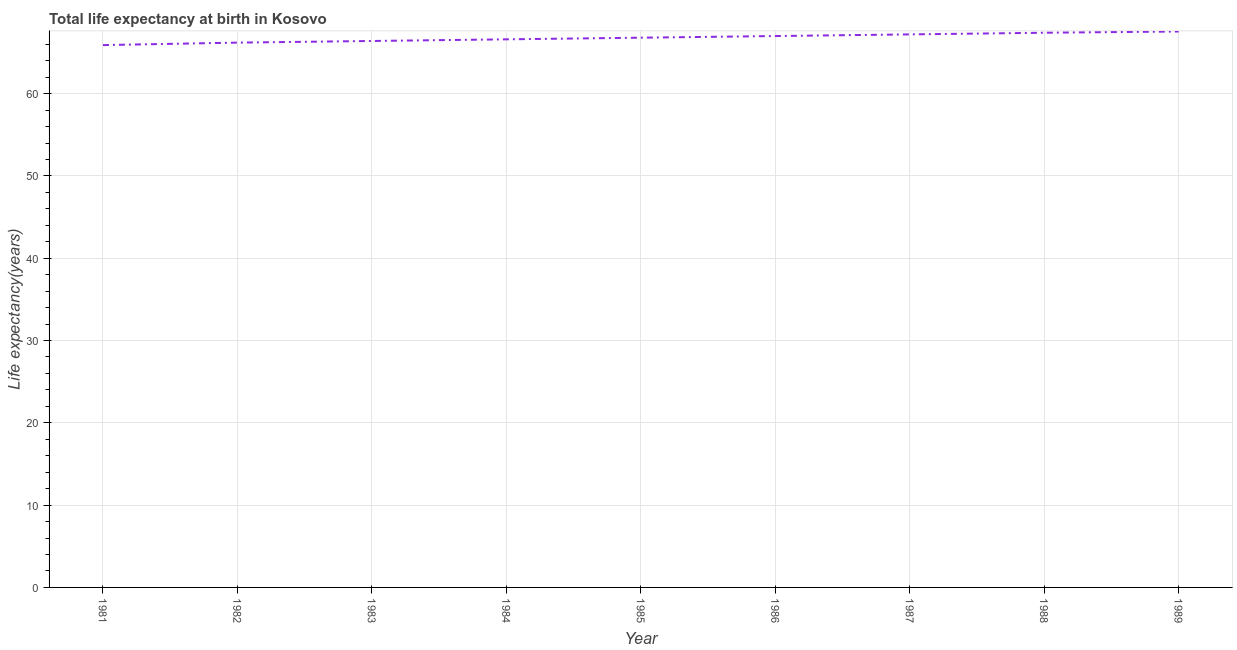What is the life expectancy at birth in 1985?
Offer a very short reply. 66.8. Across all years, what is the maximum life expectancy at birth?
Offer a very short reply. 67.55. Across all years, what is the minimum life expectancy at birth?
Your answer should be compact. 65.9. In which year was the life expectancy at birth maximum?
Your response must be concise. 1989. In which year was the life expectancy at birth minimum?
Your response must be concise. 1981. What is the sum of the life expectancy at birth?
Make the answer very short. 601.03. What is the difference between the life expectancy at birth in 1984 and 1988?
Your response must be concise. -0.8. What is the average life expectancy at birth per year?
Offer a terse response. 66.78. What is the median life expectancy at birth?
Provide a short and direct response. 66.8. Do a majority of the years between 1982 and 1986 (inclusive) have life expectancy at birth greater than 64 years?
Make the answer very short. Yes. What is the ratio of the life expectancy at birth in 1986 to that in 1987?
Offer a very short reply. 1. Is the life expectancy at birth in 1984 less than that in 1986?
Provide a short and direct response. Yes. What is the difference between the highest and the second highest life expectancy at birth?
Offer a very short reply. 0.15. What is the difference between the highest and the lowest life expectancy at birth?
Your response must be concise. 1.65. How many years are there in the graph?
Keep it short and to the point. 9. Does the graph contain grids?
Keep it short and to the point. Yes. What is the title of the graph?
Your answer should be very brief. Total life expectancy at birth in Kosovo. What is the label or title of the X-axis?
Offer a terse response. Year. What is the label or title of the Y-axis?
Provide a short and direct response. Life expectancy(years). What is the Life expectancy(years) of 1981?
Offer a very short reply. 65.9. What is the Life expectancy(years) of 1982?
Offer a very short reply. 66.2. What is the Life expectancy(years) of 1983?
Keep it short and to the point. 66.4. What is the Life expectancy(years) in 1984?
Offer a very short reply. 66.6. What is the Life expectancy(years) in 1985?
Keep it short and to the point. 66.8. What is the Life expectancy(years) in 1986?
Provide a short and direct response. 67. What is the Life expectancy(years) in 1987?
Provide a short and direct response. 67.2. What is the Life expectancy(years) of 1988?
Offer a very short reply. 67.4. What is the Life expectancy(years) of 1989?
Make the answer very short. 67.55. What is the difference between the Life expectancy(years) in 1981 and 1983?
Offer a terse response. -0.5. What is the difference between the Life expectancy(years) in 1981 and 1985?
Offer a very short reply. -0.9. What is the difference between the Life expectancy(years) in 1981 and 1986?
Your response must be concise. -1.1. What is the difference between the Life expectancy(years) in 1981 and 1987?
Offer a very short reply. -1.3. What is the difference between the Life expectancy(years) in 1981 and 1988?
Your answer should be compact. -1.5. What is the difference between the Life expectancy(years) in 1981 and 1989?
Ensure brevity in your answer.  -1.65. What is the difference between the Life expectancy(years) in 1982 and 1984?
Provide a succinct answer. -0.4. What is the difference between the Life expectancy(years) in 1982 and 1986?
Your response must be concise. -0.8. What is the difference between the Life expectancy(years) in 1982 and 1987?
Give a very brief answer. -1. What is the difference between the Life expectancy(years) in 1982 and 1988?
Your answer should be compact. -1.2. What is the difference between the Life expectancy(years) in 1982 and 1989?
Keep it short and to the point. -1.35. What is the difference between the Life expectancy(years) in 1983 and 1984?
Make the answer very short. -0.2. What is the difference between the Life expectancy(years) in 1983 and 1987?
Ensure brevity in your answer.  -0.8. What is the difference between the Life expectancy(years) in 1983 and 1989?
Provide a succinct answer. -1.15. What is the difference between the Life expectancy(years) in 1984 and 1985?
Your answer should be very brief. -0.2. What is the difference between the Life expectancy(years) in 1984 and 1989?
Provide a short and direct response. -0.95. What is the difference between the Life expectancy(years) in 1985 and 1986?
Your answer should be compact. -0.2. What is the difference between the Life expectancy(years) in 1985 and 1987?
Ensure brevity in your answer.  -0.4. What is the difference between the Life expectancy(years) in 1985 and 1989?
Ensure brevity in your answer.  -0.75. What is the difference between the Life expectancy(years) in 1986 and 1987?
Make the answer very short. -0.2. What is the difference between the Life expectancy(years) in 1986 and 1988?
Ensure brevity in your answer.  -0.4. What is the difference between the Life expectancy(years) in 1986 and 1989?
Provide a succinct answer. -0.55. What is the difference between the Life expectancy(years) in 1987 and 1988?
Offer a terse response. -0.2. What is the difference between the Life expectancy(years) in 1987 and 1989?
Offer a very short reply. -0.35. What is the difference between the Life expectancy(years) in 1988 and 1989?
Provide a succinct answer. -0.15. What is the ratio of the Life expectancy(years) in 1981 to that in 1983?
Offer a very short reply. 0.99. What is the ratio of the Life expectancy(years) in 1981 to that in 1984?
Your answer should be very brief. 0.99. What is the ratio of the Life expectancy(years) in 1981 to that in 1985?
Your response must be concise. 0.99. What is the ratio of the Life expectancy(years) in 1981 to that in 1986?
Give a very brief answer. 0.98. What is the ratio of the Life expectancy(years) in 1981 to that in 1987?
Provide a short and direct response. 0.98. What is the ratio of the Life expectancy(years) in 1981 to that in 1988?
Make the answer very short. 0.98. What is the ratio of the Life expectancy(years) in 1982 to that in 1985?
Give a very brief answer. 0.99. What is the ratio of the Life expectancy(years) in 1982 to that in 1986?
Your response must be concise. 0.99. What is the ratio of the Life expectancy(years) in 1982 to that in 1988?
Ensure brevity in your answer.  0.98. What is the ratio of the Life expectancy(years) in 1983 to that in 1985?
Keep it short and to the point. 0.99. What is the ratio of the Life expectancy(years) in 1983 to that in 1987?
Your answer should be very brief. 0.99. What is the ratio of the Life expectancy(years) in 1983 to that in 1989?
Ensure brevity in your answer.  0.98. What is the ratio of the Life expectancy(years) in 1984 to that in 1985?
Offer a very short reply. 1. What is the ratio of the Life expectancy(years) in 1984 to that in 1986?
Offer a very short reply. 0.99. What is the ratio of the Life expectancy(years) in 1984 to that in 1987?
Keep it short and to the point. 0.99. What is the ratio of the Life expectancy(years) in 1985 to that in 1986?
Your answer should be compact. 1. What is the ratio of the Life expectancy(years) in 1986 to that in 1987?
Offer a very short reply. 1. What is the ratio of the Life expectancy(years) in 1986 to that in 1988?
Your answer should be very brief. 0.99. What is the ratio of the Life expectancy(years) in 1986 to that in 1989?
Keep it short and to the point. 0.99. What is the ratio of the Life expectancy(years) in 1987 to that in 1988?
Your response must be concise. 1. What is the ratio of the Life expectancy(years) in 1988 to that in 1989?
Your response must be concise. 1. 